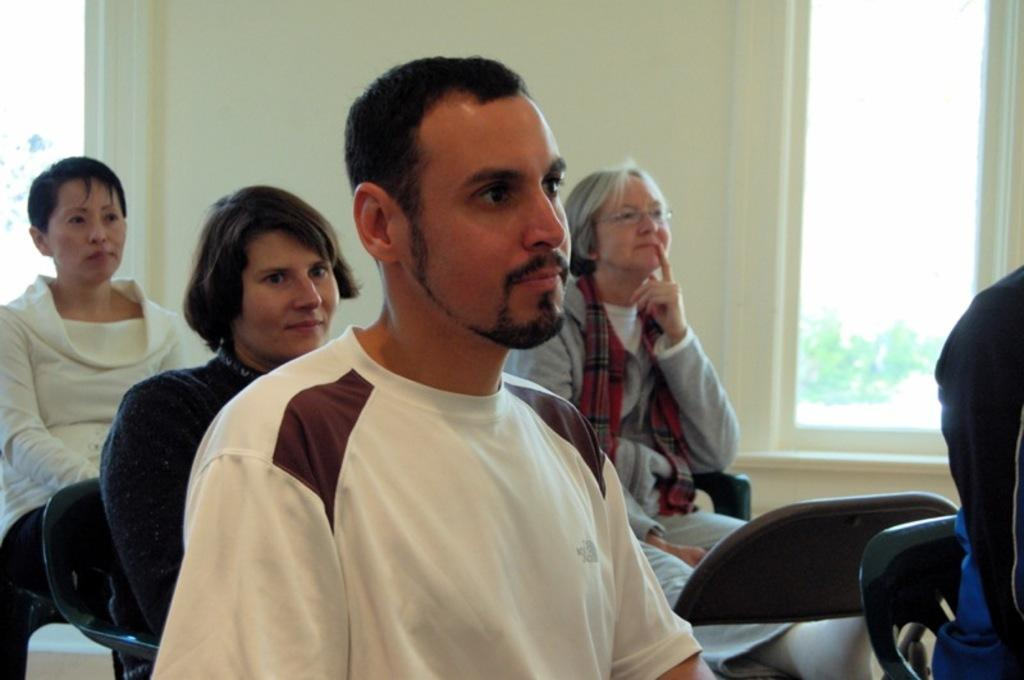What are the people in the image doing? The people in the image are sitting on chairs and paying attention towards something. What can be seen in the background of the image? There is a wall and a window beside the wall in the background of the image. Who is the creator of the window in the image? There is no information about the creator of the window in the image. 